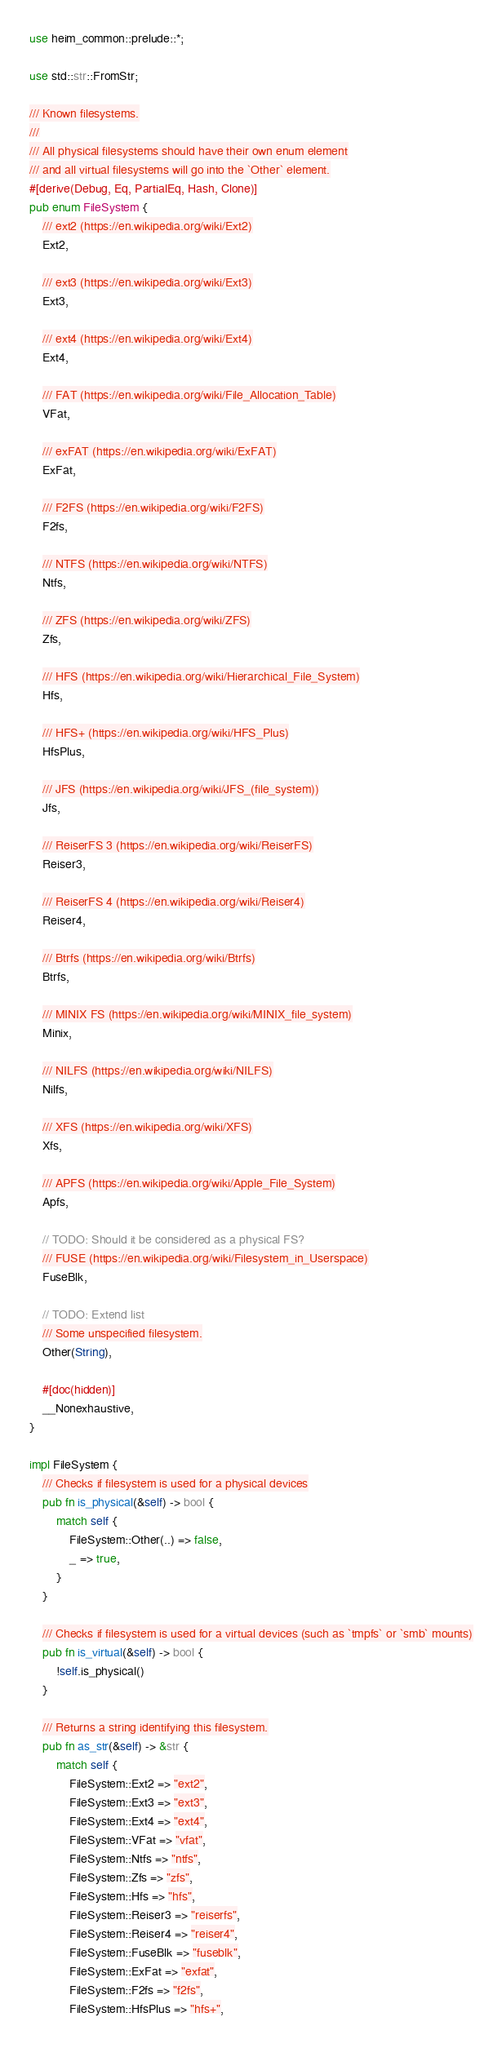Convert code to text. <code><loc_0><loc_0><loc_500><loc_500><_Rust_>use heim_common::prelude::*;

use std::str::FromStr;

/// Known filesystems.
///
/// All physical filesystems should have their own enum element
/// and all virtual filesystems will go into the `Other` element.
#[derive(Debug, Eq, PartialEq, Hash, Clone)]
pub enum FileSystem {
    /// ext2 (https://en.wikipedia.org/wiki/Ext2)
    Ext2,

    /// ext3 (https://en.wikipedia.org/wiki/Ext3)
    Ext3,

    /// ext4 (https://en.wikipedia.org/wiki/Ext4)
    Ext4,

    /// FAT (https://en.wikipedia.org/wiki/File_Allocation_Table)
    VFat,

    /// exFAT (https://en.wikipedia.org/wiki/ExFAT)
    ExFat,

    /// F2FS (https://en.wikipedia.org/wiki/F2FS)
    F2fs,

    /// NTFS (https://en.wikipedia.org/wiki/NTFS)
    Ntfs,

    /// ZFS (https://en.wikipedia.org/wiki/ZFS)
    Zfs,

    /// HFS (https://en.wikipedia.org/wiki/Hierarchical_File_System)
    Hfs,

    /// HFS+ (https://en.wikipedia.org/wiki/HFS_Plus)
    HfsPlus,

    /// JFS (https://en.wikipedia.org/wiki/JFS_(file_system))
    Jfs,

    /// ReiserFS 3 (https://en.wikipedia.org/wiki/ReiserFS)
    Reiser3,

    /// ReiserFS 4 (https://en.wikipedia.org/wiki/Reiser4)
    Reiser4,

    /// Btrfs (https://en.wikipedia.org/wiki/Btrfs)
    Btrfs,

    /// MINIX FS (https://en.wikipedia.org/wiki/MINIX_file_system)
    Minix,

    /// NILFS (https://en.wikipedia.org/wiki/NILFS)
    Nilfs,

    /// XFS (https://en.wikipedia.org/wiki/XFS)
    Xfs,

    /// APFS (https://en.wikipedia.org/wiki/Apple_File_System)
    Apfs,

    // TODO: Should it be considered as a physical FS?
    /// FUSE (https://en.wikipedia.org/wiki/Filesystem_in_Userspace)
    FuseBlk,

    // TODO: Extend list
    /// Some unspecified filesystem.
    Other(String),

    #[doc(hidden)]
    __Nonexhaustive,
}

impl FileSystem {
    /// Checks if filesystem is used for a physical devices
    pub fn is_physical(&self) -> bool {
        match self {
            FileSystem::Other(..) => false,
            _ => true,
        }
    }

    /// Checks if filesystem is used for a virtual devices (such as `tmpfs` or `smb` mounts)
    pub fn is_virtual(&self) -> bool {
        !self.is_physical()
    }

    /// Returns a string identifying this filesystem.
    pub fn as_str(&self) -> &str {
        match self {
            FileSystem::Ext2 => "ext2",
            FileSystem::Ext3 => "ext3",
            FileSystem::Ext4 => "ext4",
            FileSystem::VFat => "vfat",
            FileSystem::Ntfs => "ntfs",
            FileSystem::Zfs => "zfs",
            FileSystem::Hfs => "hfs",
            FileSystem::Reiser3 => "reiserfs",
            FileSystem::Reiser4 => "reiser4",
            FileSystem::FuseBlk => "fuseblk",
            FileSystem::ExFat => "exfat",
            FileSystem::F2fs => "f2fs",
            FileSystem::HfsPlus => "hfs+",</code> 